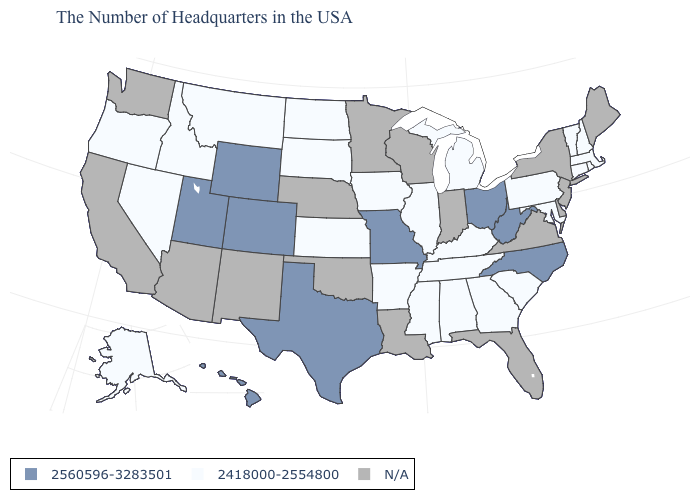Name the states that have a value in the range N/A?
Short answer required. Maine, New York, New Jersey, Delaware, Virginia, Florida, Indiana, Wisconsin, Louisiana, Minnesota, Nebraska, Oklahoma, New Mexico, Arizona, California, Washington. What is the value of California?
Keep it brief. N/A. Among the states that border New Mexico , which have the lowest value?
Write a very short answer. Texas, Colorado, Utah. What is the value of Nebraska?
Concise answer only. N/A. What is the lowest value in the USA?
Quick response, please. 2418000-2554800. Does West Virginia have the highest value in the South?
Be succinct. Yes. What is the lowest value in the USA?
Quick response, please. 2418000-2554800. Does Missouri have the lowest value in the USA?
Concise answer only. No. Name the states that have a value in the range N/A?
Short answer required. Maine, New York, New Jersey, Delaware, Virginia, Florida, Indiana, Wisconsin, Louisiana, Minnesota, Nebraska, Oklahoma, New Mexico, Arizona, California, Washington. Does the map have missing data?
Be succinct. Yes. What is the lowest value in states that border California?
Write a very short answer. 2418000-2554800. Does the map have missing data?
Quick response, please. Yes. What is the value of Wisconsin?
Be succinct. N/A. What is the lowest value in the USA?
Concise answer only. 2418000-2554800. 